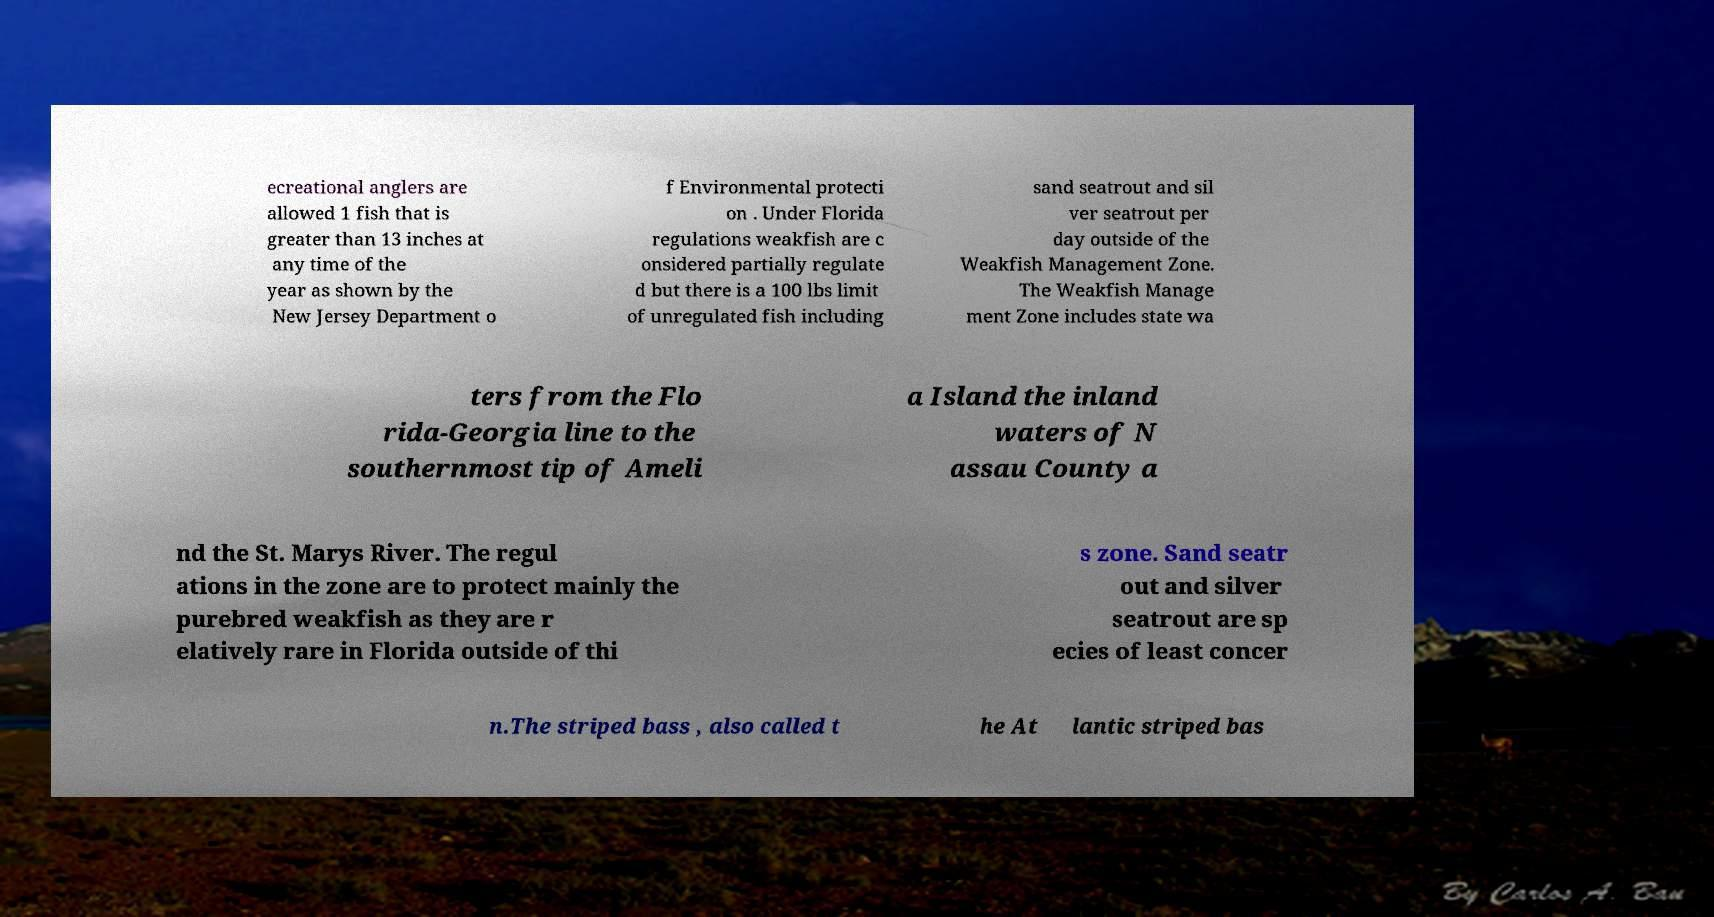Could you extract and type out the text from this image? ecreational anglers are allowed 1 fish that is greater than 13 inches at any time of the year as shown by the New Jersey Department o f Environmental protecti on . Under Florida regulations weakfish are c onsidered partially regulate d but there is a 100 lbs limit of unregulated fish including sand seatrout and sil ver seatrout per day outside of the Weakfish Management Zone. The Weakfish Manage ment Zone includes state wa ters from the Flo rida-Georgia line to the southernmost tip of Ameli a Island the inland waters of N assau County a nd the St. Marys River. The regul ations in the zone are to protect mainly the purebred weakfish as they are r elatively rare in Florida outside of thi s zone. Sand seatr out and silver seatrout are sp ecies of least concer n.The striped bass , also called t he At lantic striped bas 